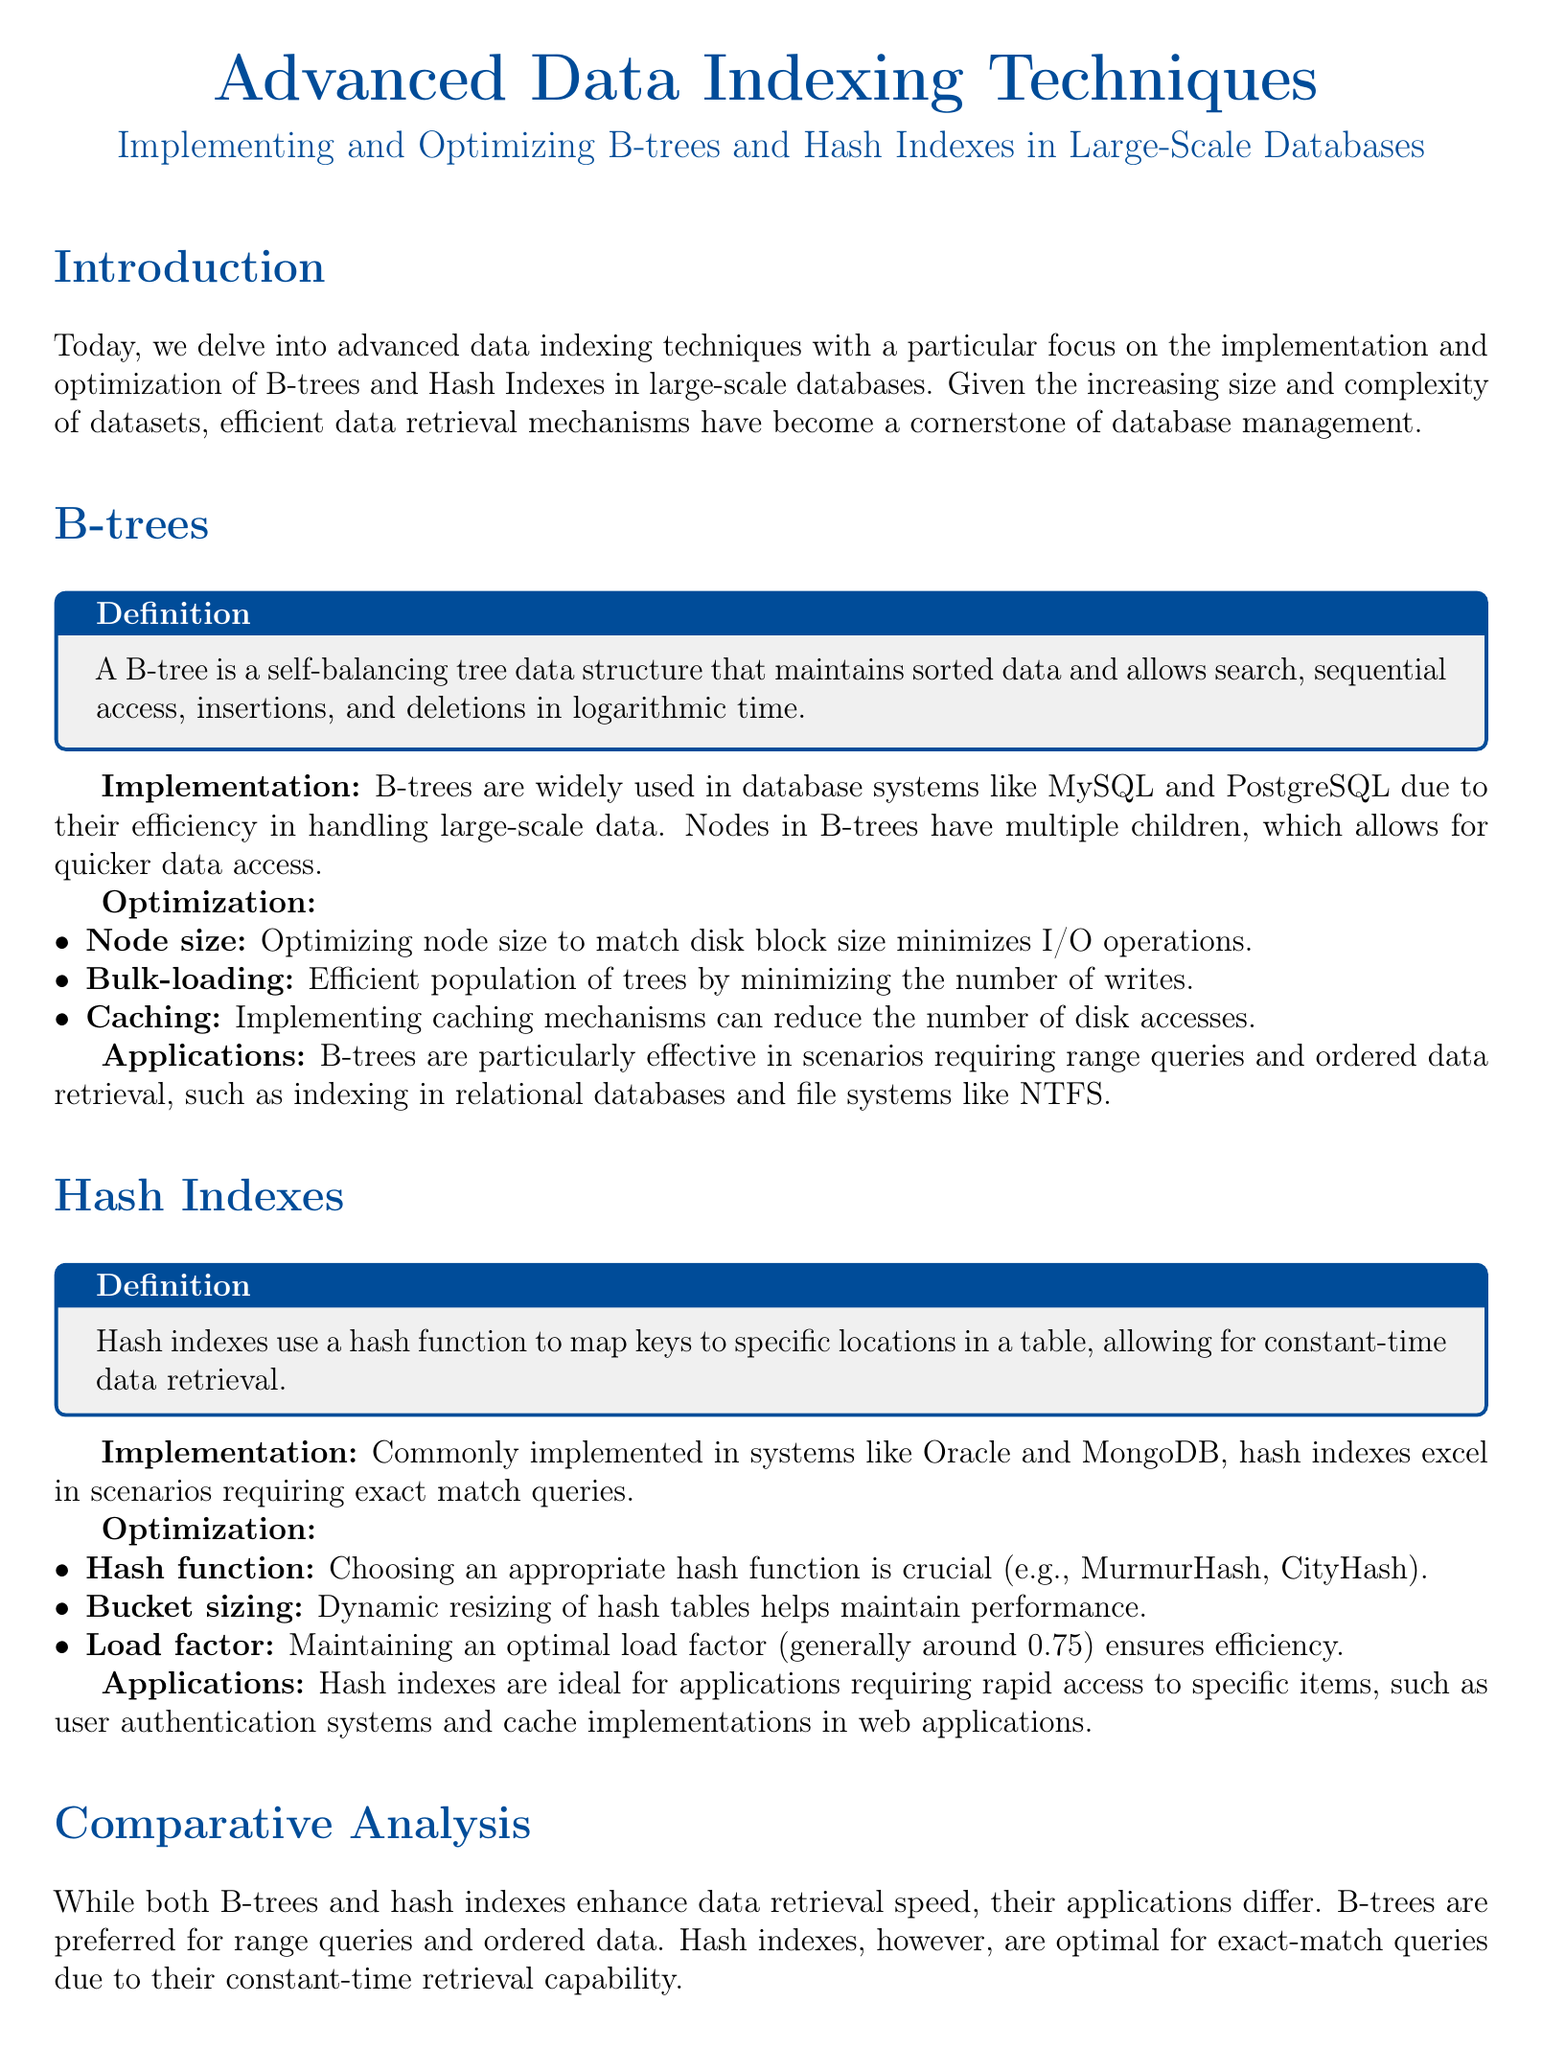What is a B-tree? A B-tree is defined in the document as a self-balancing tree data structure that maintains sorted data and allows search, sequential access, insertions, and deletions in logarithmic time.
Answer: A self-balancing tree data structure What is the primary use case for hash indexes? The document states that hash indexes excel in scenarios requiring exact match queries.
Answer: Exact match queries What is an optimization technique for B-trees regarding node size? The document mentions optimizing node size to match disk block size minimizes I/O operations.
Answer: Minimize I/O operations What is the ideal load factor for hash indexes? The document specifies maintaining an optimal load factor, generally around 0.75, ensures efficiency.
Answer: 0.75 Which database systems commonly implement B-trees? The document lists MySQL and PostgreSQL as commonly using B-trees due to their efficiency in handling large-scale data.
Answer: MySQL and PostgreSQL What key feature distinguishes B-trees from hash indexes? The document states that B-trees are preferred for range queries and ordered data, while hash indexes are optimal for exact-match queries.
Answer: Range queries and ordered data In what applications are hash indexes ideal? The document indicates hash indexes are ideal for applications requiring rapid access to specific items, such as user authentication systems.
Answer: User authentication systems What is the main focus of this document? The document focuses on advanced data indexing techniques, specifically on B-trees and hash indexes in large-scale databases.
Answer: Advanced data indexing techniques 